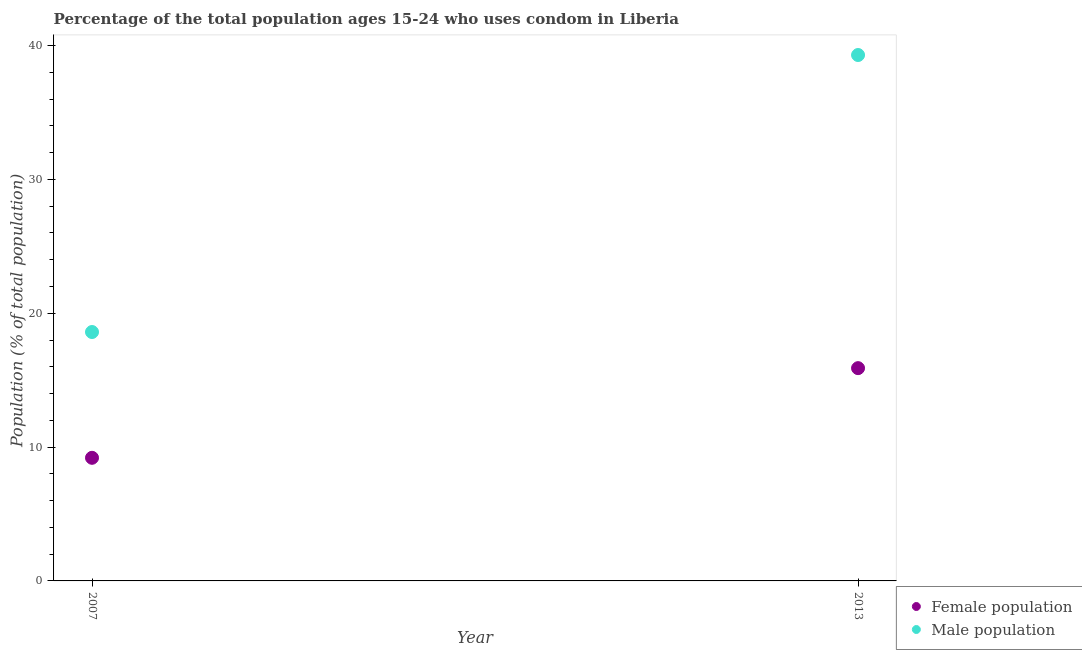How many different coloured dotlines are there?
Provide a succinct answer. 2. Is the number of dotlines equal to the number of legend labels?
Your response must be concise. Yes. What is the male population in 2007?
Your answer should be very brief. 18.6. Across all years, what is the maximum male population?
Provide a short and direct response. 39.3. In which year was the male population maximum?
Give a very brief answer. 2013. In which year was the male population minimum?
Make the answer very short. 2007. What is the total female population in the graph?
Provide a succinct answer. 25.1. What is the difference between the female population in 2007 and that in 2013?
Offer a very short reply. -6.7. What is the difference between the female population in 2007 and the male population in 2013?
Offer a terse response. -30.1. What is the average male population per year?
Offer a terse response. 28.95. In the year 2007, what is the difference between the female population and male population?
Provide a succinct answer. -9.4. What is the ratio of the male population in 2007 to that in 2013?
Offer a terse response. 0.47. Is the female population strictly greater than the male population over the years?
Provide a short and direct response. No. Is the male population strictly less than the female population over the years?
Offer a very short reply. No. Are the values on the major ticks of Y-axis written in scientific E-notation?
Make the answer very short. No. Does the graph contain grids?
Ensure brevity in your answer.  No. How many legend labels are there?
Offer a terse response. 2. What is the title of the graph?
Keep it short and to the point. Percentage of the total population ages 15-24 who uses condom in Liberia. Does "External balance on goods" appear as one of the legend labels in the graph?
Give a very brief answer. No. What is the label or title of the X-axis?
Your answer should be compact. Year. What is the label or title of the Y-axis?
Your answer should be compact. Population (% of total population) . What is the Population (% of total population)  in Female population in 2007?
Provide a short and direct response. 9.2. What is the Population (% of total population)  of Male population in 2007?
Offer a terse response. 18.6. What is the Population (% of total population)  in Male population in 2013?
Your answer should be compact. 39.3. Across all years, what is the maximum Population (% of total population)  in Female population?
Your answer should be compact. 15.9. Across all years, what is the maximum Population (% of total population)  of Male population?
Make the answer very short. 39.3. Across all years, what is the minimum Population (% of total population)  of Male population?
Offer a terse response. 18.6. What is the total Population (% of total population)  in Female population in the graph?
Offer a very short reply. 25.1. What is the total Population (% of total population)  of Male population in the graph?
Your response must be concise. 57.9. What is the difference between the Population (% of total population)  in Female population in 2007 and that in 2013?
Provide a succinct answer. -6.7. What is the difference between the Population (% of total population)  of Male population in 2007 and that in 2013?
Provide a succinct answer. -20.7. What is the difference between the Population (% of total population)  in Female population in 2007 and the Population (% of total population)  in Male population in 2013?
Keep it short and to the point. -30.1. What is the average Population (% of total population)  in Female population per year?
Your answer should be very brief. 12.55. What is the average Population (% of total population)  in Male population per year?
Make the answer very short. 28.95. In the year 2007, what is the difference between the Population (% of total population)  of Female population and Population (% of total population)  of Male population?
Your answer should be compact. -9.4. In the year 2013, what is the difference between the Population (% of total population)  in Female population and Population (% of total population)  in Male population?
Make the answer very short. -23.4. What is the ratio of the Population (% of total population)  of Female population in 2007 to that in 2013?
Offer a terse response. 0.58. What is the ratio of the Population (% of total population)  in Male population in 2007 to that in 2013?
Make the answer very short. 0.47. What is the difference between the highest and the second highest Population (% of total population)  of Female population?
Your answer should be compact. 6.7. What is the difference between the highest and the second highest Population (% of total population)  in Male population?
Offer a terse response. 20.7. What is the difference between the highest and the lowest Population (% of total population)  in Male population?
Your response must be concise. 20.7. 